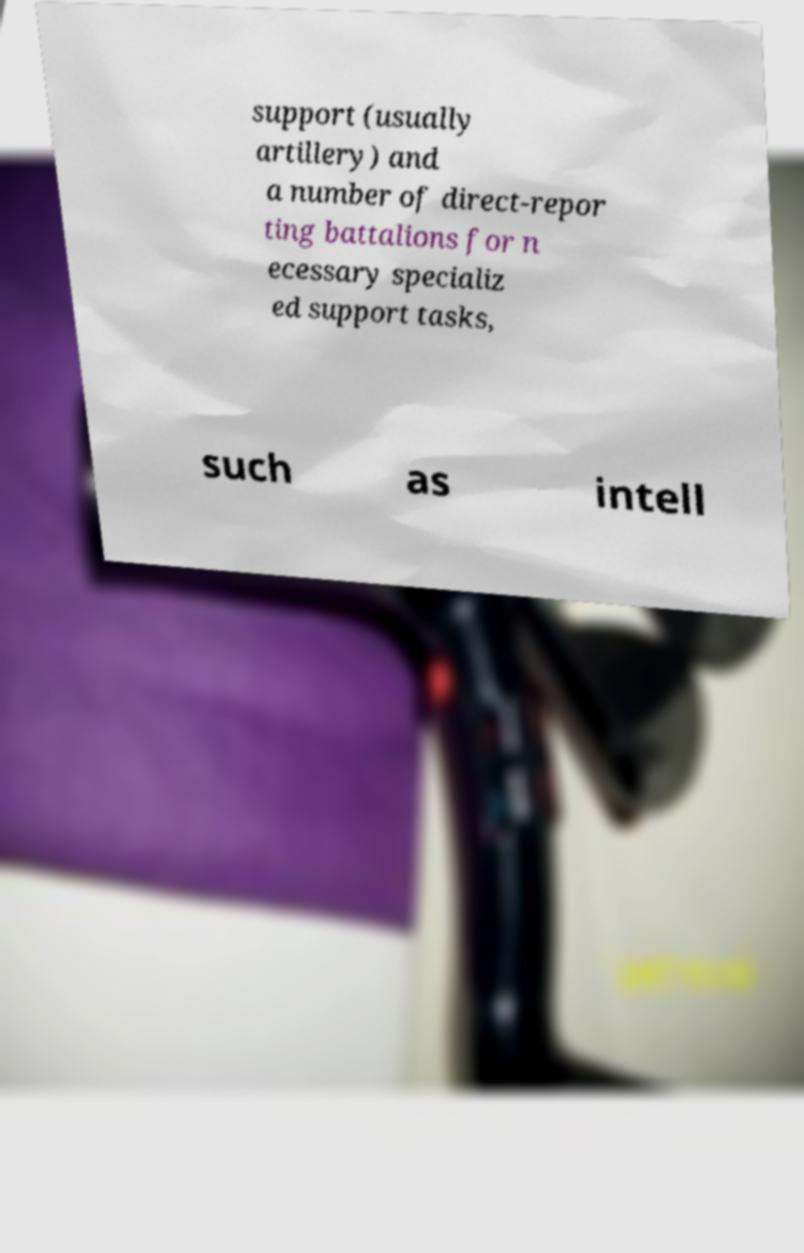Can you accurately transcribe the text from the provided image for me? support (usually artillery) and a number of direct-repor ting battalions for n ecessary specializ ed support tasks, such as intell 